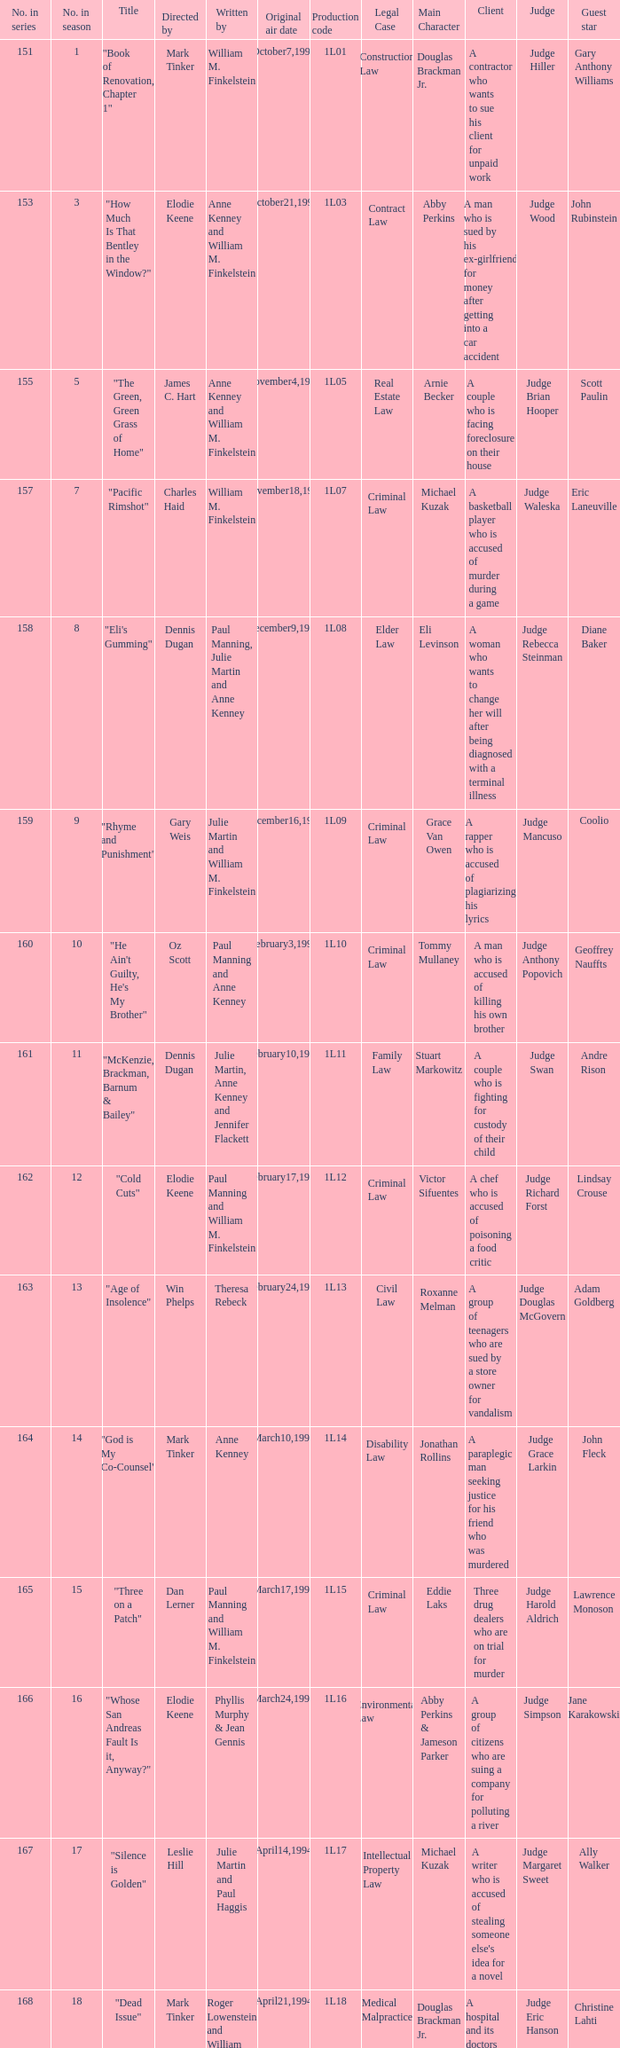Name the production code for theresa rebeck 1L13. 